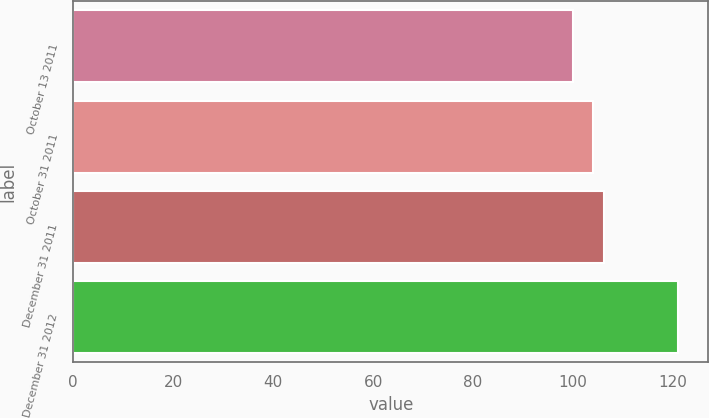Convert chart. <chart><loc_0><loc_0><loc_500><loc_500><bar_chart><fcel>October 13 2011<fcel>October 31 2011<fcel>December 31 2011<fcel>December 31 2012<nl><fcel>100<fcel>104<fcel>106.1<fcel>121<nl></chart> 